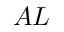Convert formula to latex. <formula><loc_0><loc_0><loc_500><loc_500>A L</formula> 